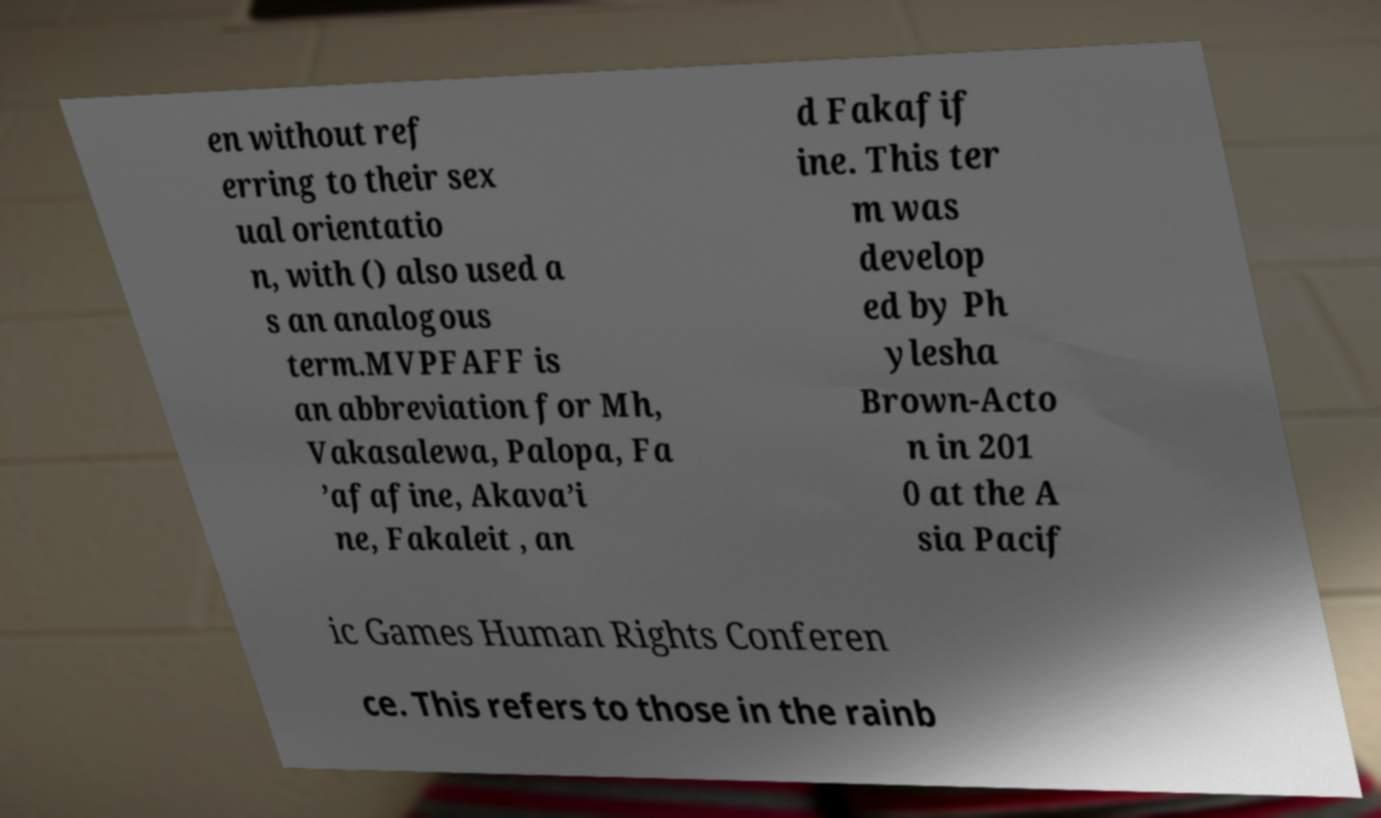Please read and relay the text visible in this image. What does it say? en without ref erring to their sex ual orientatio n, with () also used a s an analogous term.MVPFAFF is an abbreviation for Mh, Vakasalewa, Palopa, Fa ’afafine, Akava’i ne, Fakaleit , an d Fakafif ine. This ter m was develop ed by Ph ylesha Brown-Acto n in 201 0 at the A sia Pacif ic Games Human Rights Conferen ce. This refers to those in the rainb 